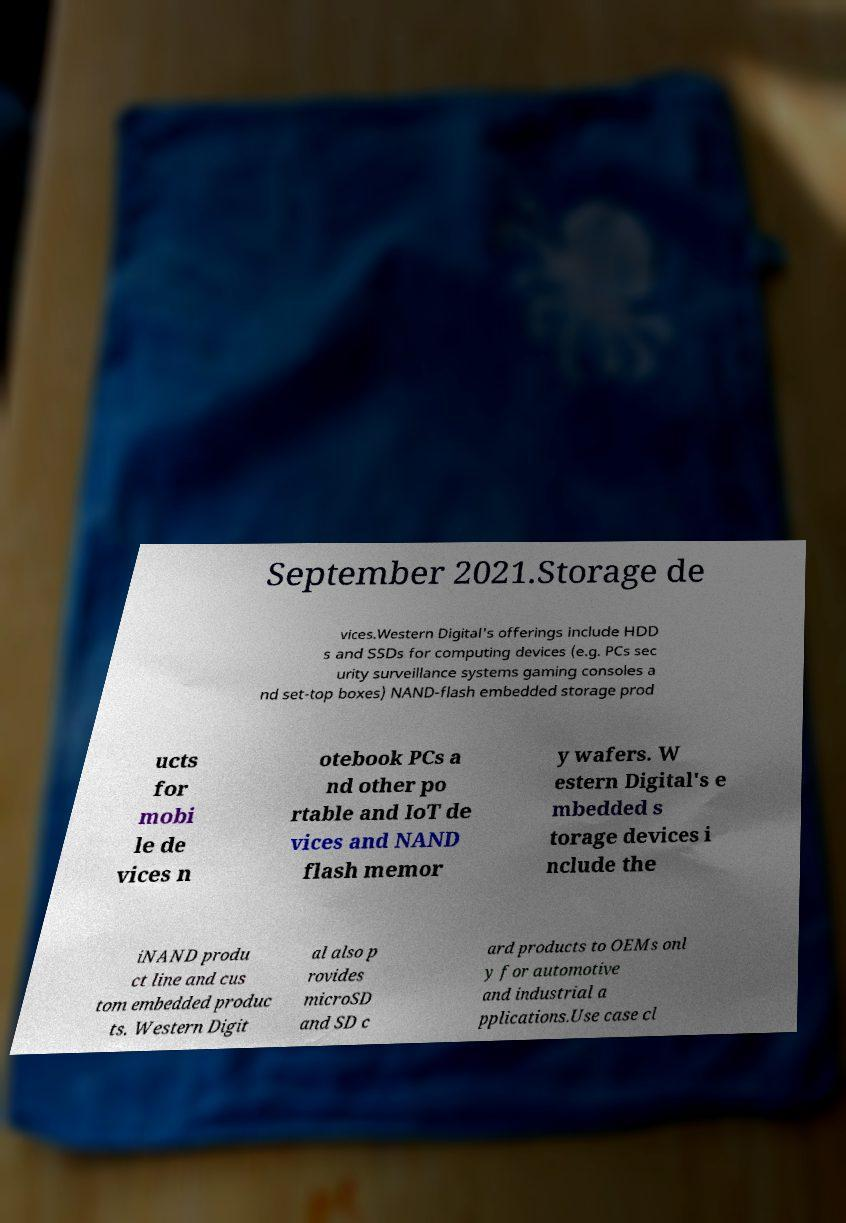What messages or text are displayed in this image? I need them in a readable, typed format. September 2021.Storage de vices.Western Digital's offerings include HDD s and SSDs for computing devices (e.g. PCs sec urity surveillance systems gaming consoles a nd set-top boxes) NAND-flash embedded storage prod ucts for mobi le de vices n otebook PCs a nd other po rtable and IoT de vices and NAND flash memor y wafers. W estern Digital's e mbedded s torage devices i nclude the iNAND produ ct line and cus tom embedded produc ts. Western Digit al also p rovides microSD and SD c ard products to OEMs onl y for automotive and industrial a pplications.Use case cl 